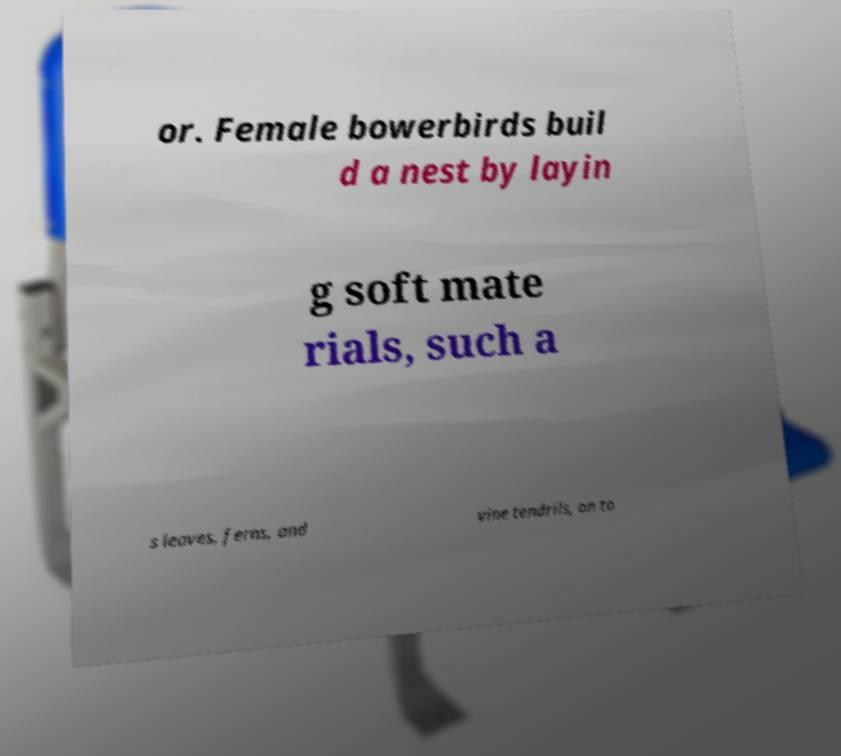Could you assist in decoding the text presented in this image and type it out clearly? or. Female bowerbirds buil d a nest by layin g soft mate rials, such a s leaves, ferns, and vine tendrils, on to 